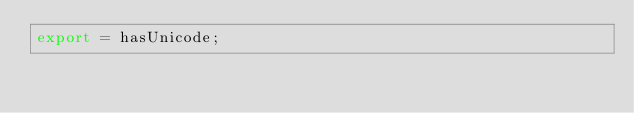<code> <loc_0><loc_0><loc_500><loc_500><_TypeScript_>export = hasUnicode;
</code> 